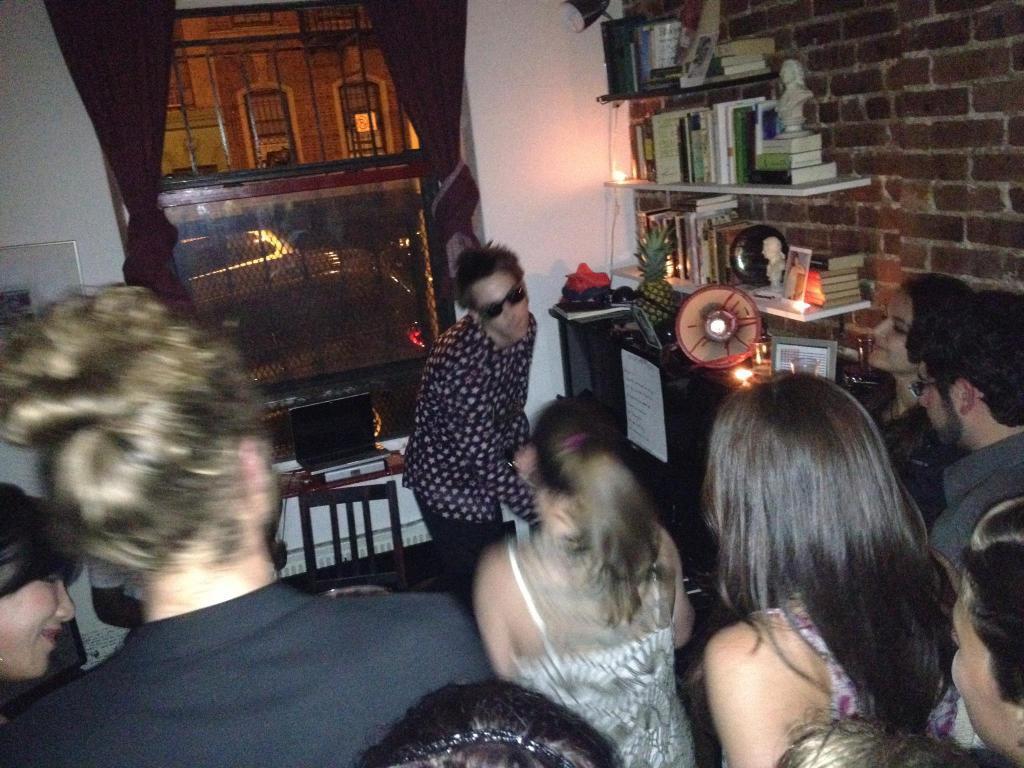Can you describe this image briefly? In this image there are people standing. In front of them there is a wall. There is a window to the wall. In front of the window there is a laptop on a stool. Beside the window there is a wooden cabinet. There are fruits, picture frames and candles on the cabinet. Above the cabinet there are shelves. There are books, sculptures and frames on the shelves. There are curtains to the window. Outside the window there are vehicles moving on the road. Behind the vehicles there is a building. 